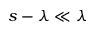<formula> <loc_0><loc_0><loc_500><loc_500>s - \lambda \ll \lambda</formula> 